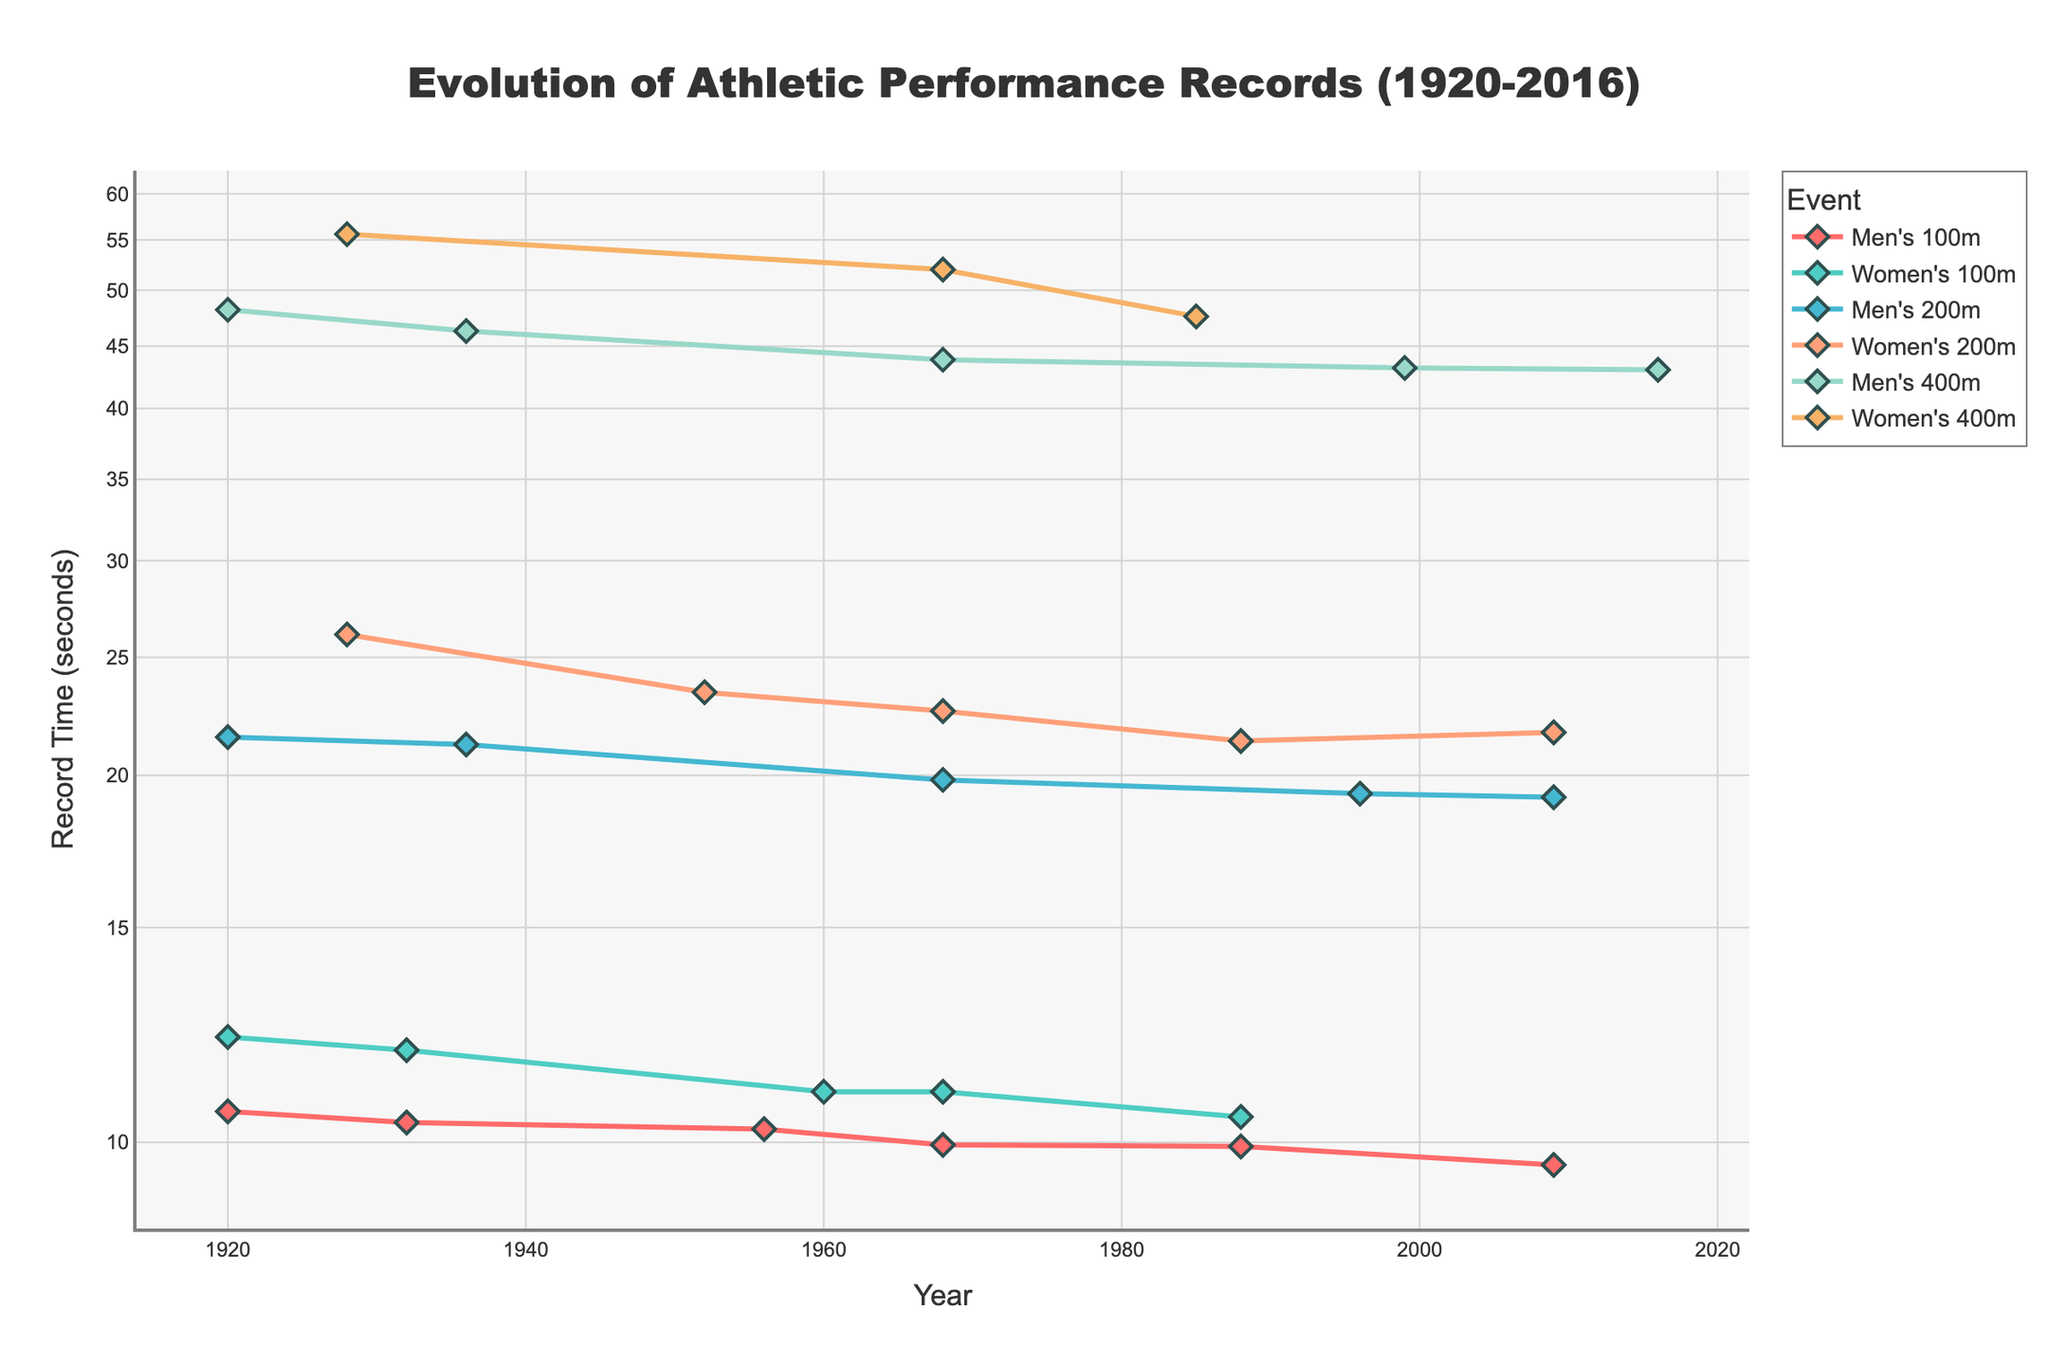What is the title of the figure? The title of the figure is prominently displayed at the top.
Answer: Evolution of Athletic Performance Records (1920-2016) What is the Y-axis title, and what scale is used? The Y-axis title is clearly written, and the axis is set to a logarithmic scale.
Answer: Record Time (seconds), log scale How many events are represented in the figure? The legend or the different colored lines can be counted to find the number of unique events.
Answer: 6 Which men's event demonstrated the most significant improvement in record time from 1920 to 2016? Look at the lines representing men's events and observe the one with the greatest decline in record times from 1920 to 2016.
Answer: Men's 400m How many years passed between the two record times in the women's 100m event that were both set at 11.00 seconds? Identify the years in the dataset where the women's 100m record was 11.00 seconds, and then calculate the difference.
Answer: 8 years (1960 and 1968) Which event had the fastest recorded time overall, and what year was it set? Look for the lowest point on the graph and check the corresponding event and year.
Answer: Men's 100m, 2009 (9.58 seconds) What trend is observed in the men's 200m event from 1920 to 2009? Follow the line representing the men's 200m event and describe the general direction over the years.
Answer: Steady decrease Compare the women's 200m and 400m world record times in 1988 and 2016. Which event shows a better improvement, and by how much? Compare the points for the women's 200m and 400m in 1988 and 2016, and calculate the difference in improvement.
Answer: Women's 400m improved more (from 47.60 in 1985 to not-listed in later years vs. women's 200m from 21.34 in 1988 to 21.69 in 2009) By how many seconds did the men's 100m record improve between 1932 and 1968? Subtract the record time in 1968 from the record time in 1932 for the men's 100m event.
Answer: 0.43 seconds What is the general trend for women's track events in terms of record improvements over the century? Observe the overall movement of the lines representing women's events from the early 1900s to the 2000s.
Answer: General decrease in record times 